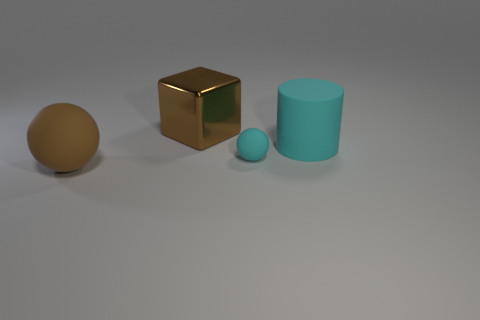Is there anything else that is the same shape as the large cyan matte object?
Your answer should be compact. No. What number of things are large matte things left of the big cyan matte object or small red things?
Give a very brief answer. 1. There is a sphere that is made of the same material as the small thing; what color is it?
Provide a succinct answer. Brown. Are there any brown balls of the same size as the matte cylinder?
Give a very brief answer. Yes. What number of objects are either matte things that are right of the tiny thing or large objects that are on the right side of the big brown block?
Give a very brief answer. 1. The brown thing that is the same size as the brown cube is what shape?
Offer a very short reply. Sphere. Are there any other large red things that have the same shape as the large metallic object?
Provide a short and direct response. No. Is the number of big cyan rubber cylinders less than the number of cyan matte things?
Your answer should be very brief. Yes. Does the cyan rubber object in front of the big cyan thing have the same size as the cyan thing that is behind the small matte sphere?
Give a very brief answer. No. What number of objects are tiny cyan balls or brown metal things?
Provide a short and direct response. 2. 